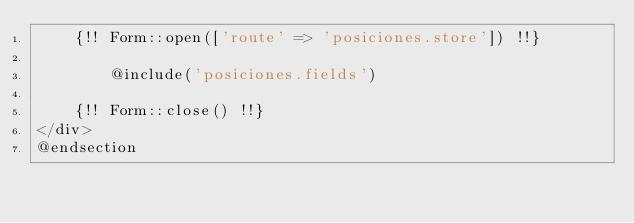<code> <loc_0><loc_0><loc_500><loc_500><_PHP_>    {!! Form::open(['route' => 'posiciones.store']) !!}

        @include('posiciones.fields')

    {!! Form::close() !!}
</div>
@endsection
</code> 